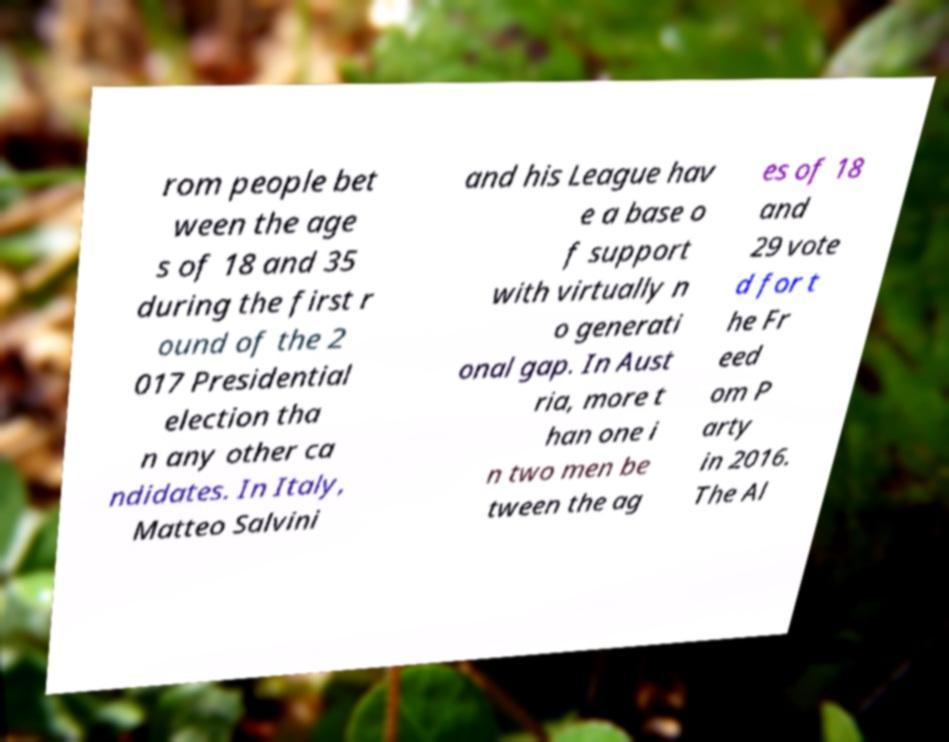Could you assist in decoding the text presented in this image and type it out clearly? rom people bet ween the age s of 18 and 35 during the first r ound of the 2 017 Presidential election tha n any other ca ndidates. In Italy, Matteo Salvini and his League hav e a base o f support with virtually n o generati onal gap. In Aust ria, more t han one i n two men be tween the ag es of 18 and 29 vote d for t he Fr eed om P arty in 2016. The Al 